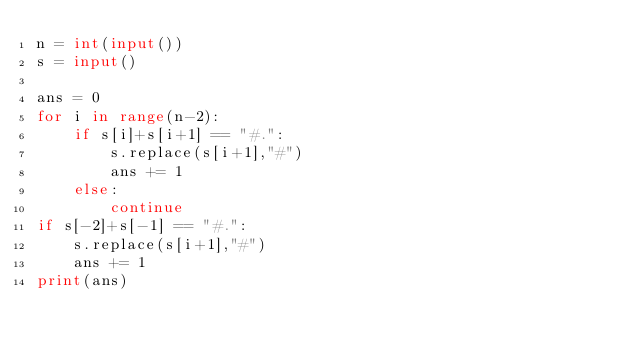Convert code to text. <code><loc_0><loc_0><loc_500><loc_500><_Python_>n = int(input())
s = input()

ans = 0
for i in range(n-2):
    if s[i]+s[i+1] == "#.":
        s.replace(s[i+1],"#")
        ans += 1
    else:
        continue
if s[-2]+s[-1] == "#.":
    s.replace(s[i+1],"#")
    ans += 1
print(ans)</code> 